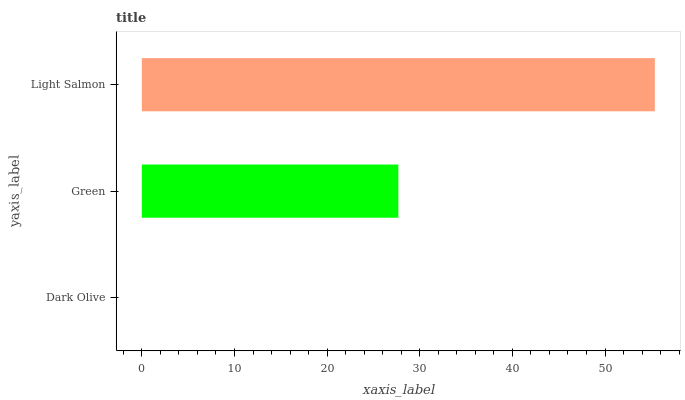Is Dark Olive the minimum?
Answer yes or no. Yes. Is Light Salmon the maximum?
Answer yes or no. Yes. Is Green the minimum?
Answer yes or no. No. Is Green the maximum?
Answer yes or no. No. Is Green greater than Dark Olive?
Answer yes or no. Yes. Is Dark Olive less than Green?
Answer yes or no. Yes. Is Dark Olive greater than Green?
Answer yes or no. No. Is Green less than Dark Olive?
Answer yes or no. No. Is Green the high median?
Answer yes or no. Yes. Is Green the low median?
Answer yes or no. Yes. Is Dark Olive the high median?
Answer yes or no. No. Is Light Salmon the low median?
Answer yes or no. No. 